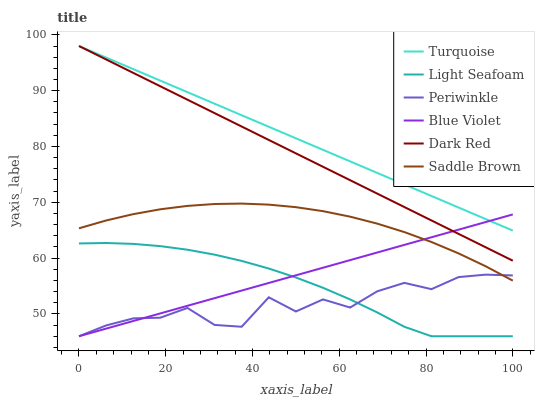Does Periwinkle have the minimum area under the curve?
Answer yes or no. Yes. Does Turquoise have the maximum area under the curve?
Answer yes or no. Yes. Does Dark Red have the minimum area under the curve?
Answer yes or no. No. Does Dark Red have the maximum area under the curve?
Answer yes or no. No. Is Dark Red the smoothest?
Answer yes or no. Yes. Is Periwinkle the roughest?
Answer yes or no. Yes. Is Periwinkle the smoothest?
Answer yes or no. No. Is Dark Red the roughest?
Answer yes or no. No. Does Periwinkle have the lowest value?
Answer yes or no. Yes. Does Dark Red have the lowest value?
Answer yes or no. No. Does Dark Red have the highest value?
Answer yes or no. Yes. Does Periwinkle have the highest value?
Answer yes or no. No. Is Periwinkle less than Dark Red?
Answer yes or no. Yes. Is Turquoise greater than Light Seafoam?
Answer yes or no. Yes. Does Light Seafoam intersect Blue Violet?
Answer yes or no. Yes. Is Light Seafoam less than Blue Violet?
Answer yes or no. No. Is Light Seafoam greater than Blue Violet?
Answer yes or no. No. Does Periwinkle intersect Dark Red?
Answer yes or no. No. 